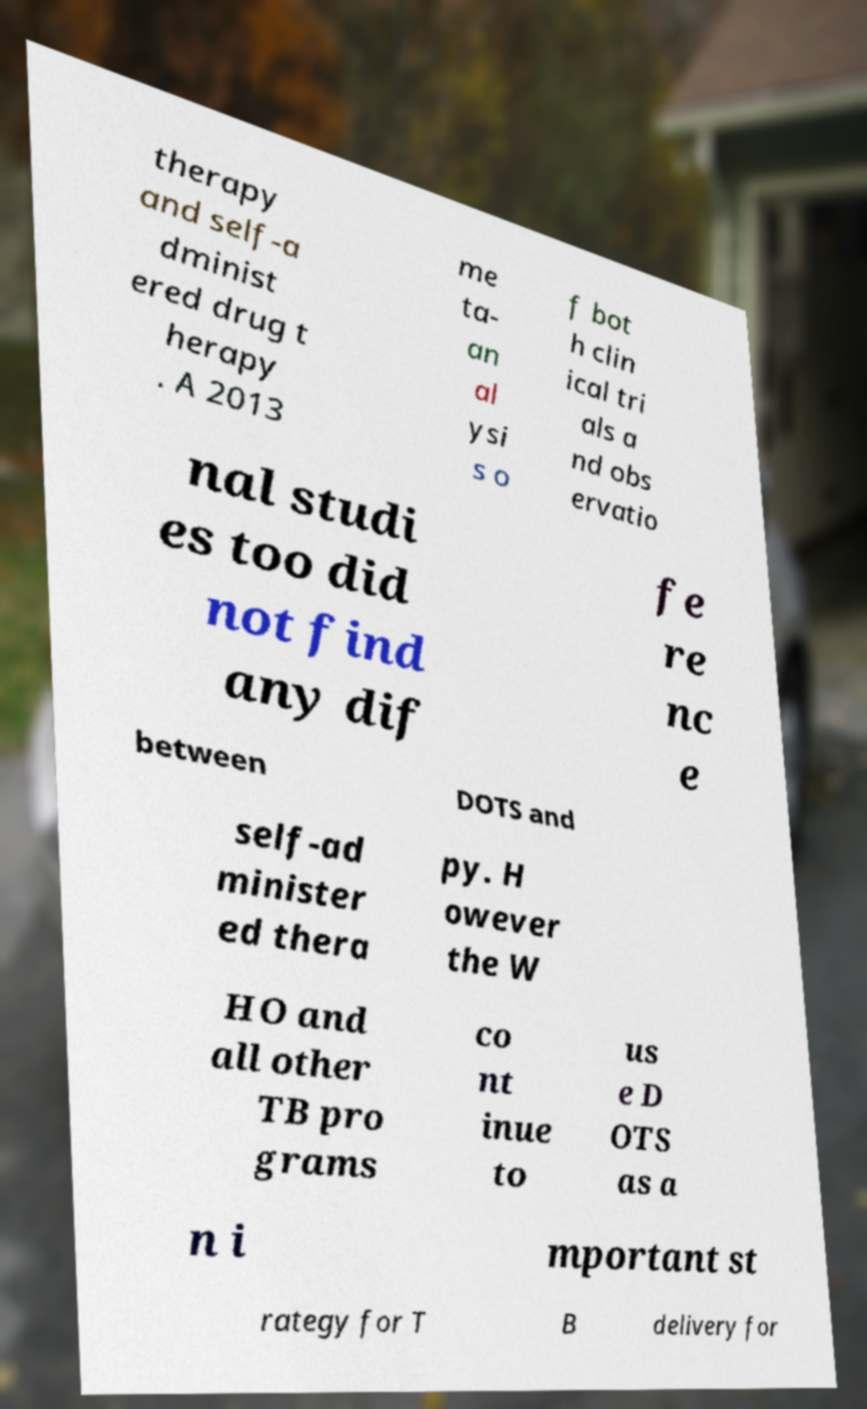I need the written content from this picture converted into text. Can you do that? therapy and self-a dminist ered drug t herapy . A 2013 me ta- an al ysi s o f bot h clin ical tri als a nd obs ervatio nal studi es too did not find any dif fe re nc e between DOTS and self-ad minister ed thera py. H owever the W HO and all other TB pro grams co nt inue to us e D OTS as a n i mportant st rategy for T B delivery for 